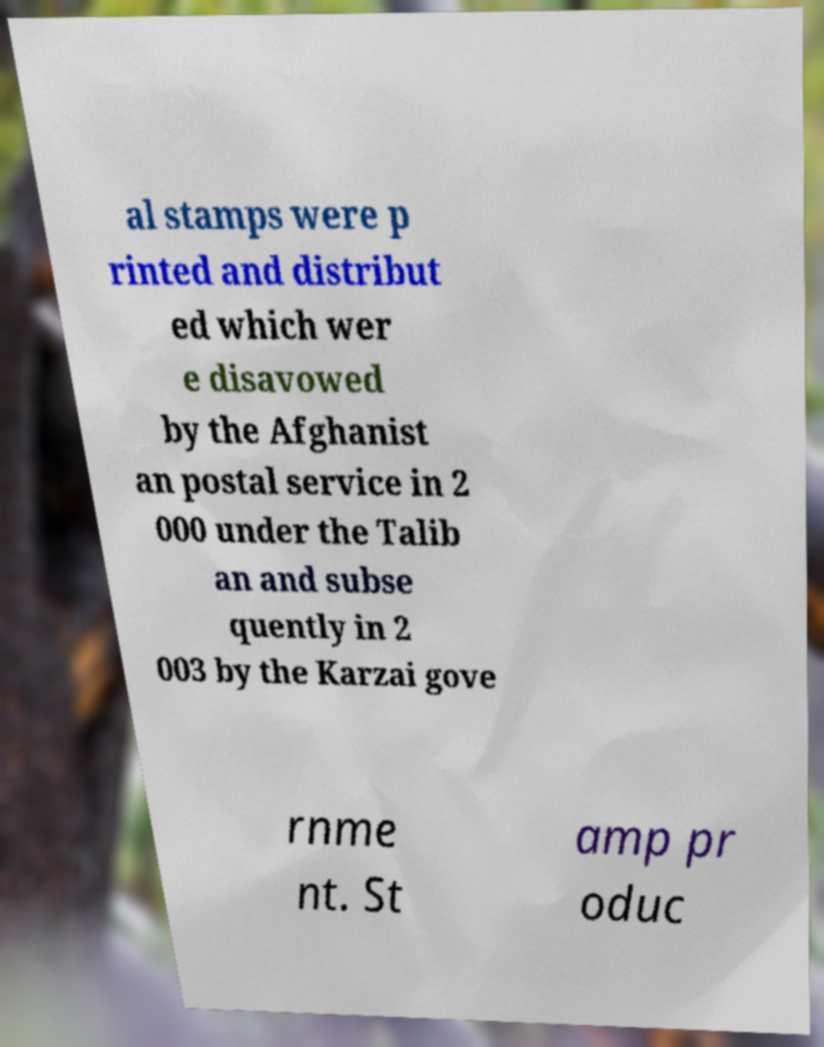There's text embedded in this image that I need extracted. Can you transcribe it verbatim? al stamps were p rinted and distribut ed which wer e disavowed by the Afghanist an postal service in 2 000 under the Talib an and subse quently in 2 003 by the Karzai gove rnme nt. St amp pr oduc 